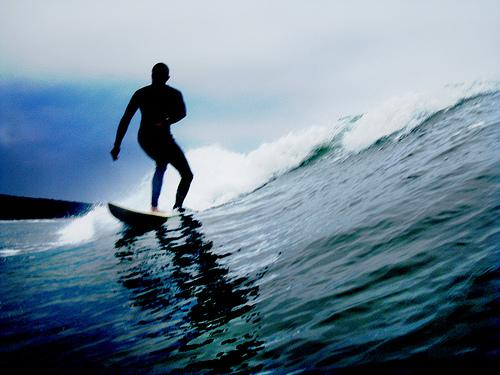Question: what sport is this?
Choices:
A. Surfing.
B. Kite surfing.
C. Wind Surfing.
D. Para-sailing.
Answer with the letter. Answer: A Question: what is covering the sky?
Choices:
A. Blue sky.
B. Stars.
C. Smog.
D. Clouds.
Answer with the letter. Answer: D Question: what is the person standing on?
Choices:
A. Surfboard.
B. A skateboard.
C. Skies.
D. A car.
Answer with the letter. Answer: A Question: where was this picture taken?
Choices:
A. At a lake.
B. Ocean.
C. In the valley.
D. In the wetlands.
Answer with the letter. Answer: B 